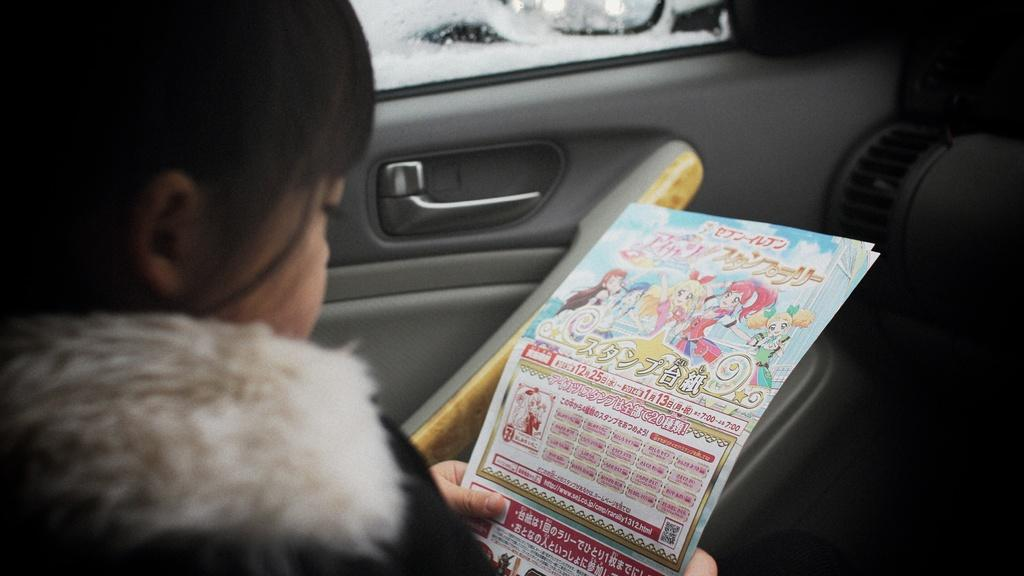Who is the main subject in the image? There is a girl in the image. What is the girl doing in the image? The girl is sitting in a car. What is the girl holding in the image? The girl is holding a paper. What channel is the girl watching on the car's TV in the image? There is no TV present in the image, so it is not possible to determine what channel the girl might be watching. 